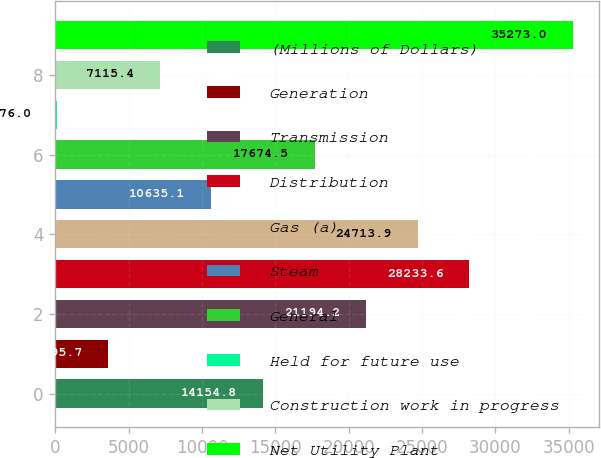<chart> <loc_0><loc_0><loc_500><loc_500><bar_chart><fcel>(Millions of Dollars)<fcel>Generation<fcel>Transmission<fcel>Distribution<fcel>Gas (a)<fcel>Steam<fcel>General<fcel>Held for future use<fcel>Construction work in progress<fcel>Net Utility Plant<nl><fcel>14154.8<fcel>3595.7<fcel>21194.2<fcel>28233.6<fcel>24713.9<fcel>10635.1<fcel>17674.5<fcel>76<fcel>7115.4<fcel>35273<nl></chart> 